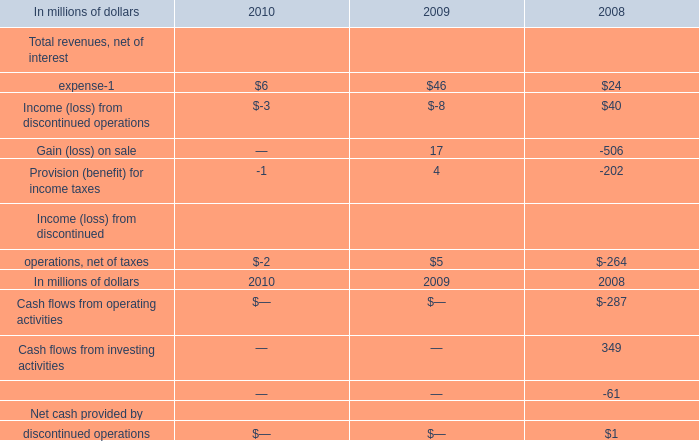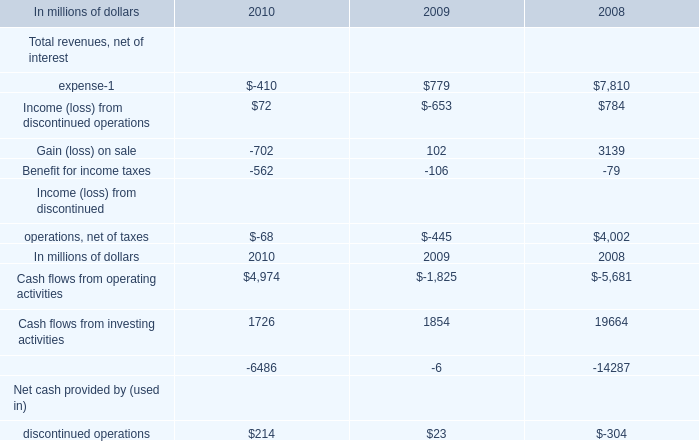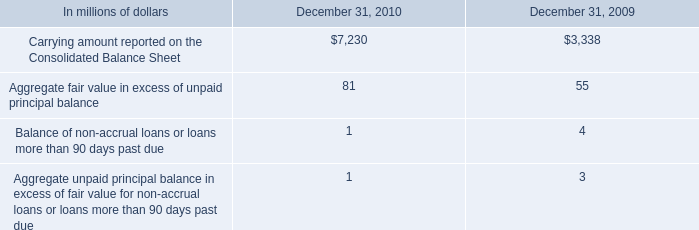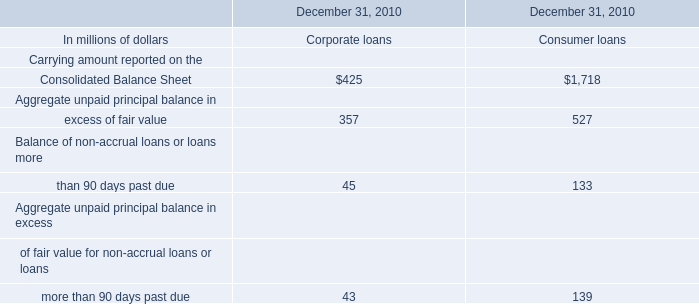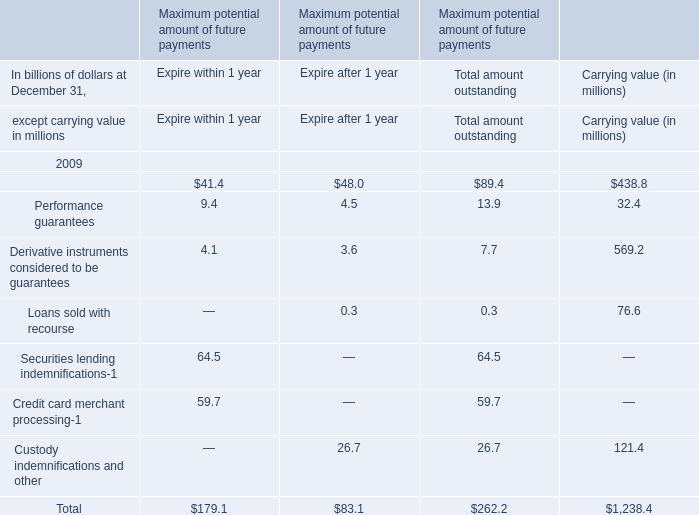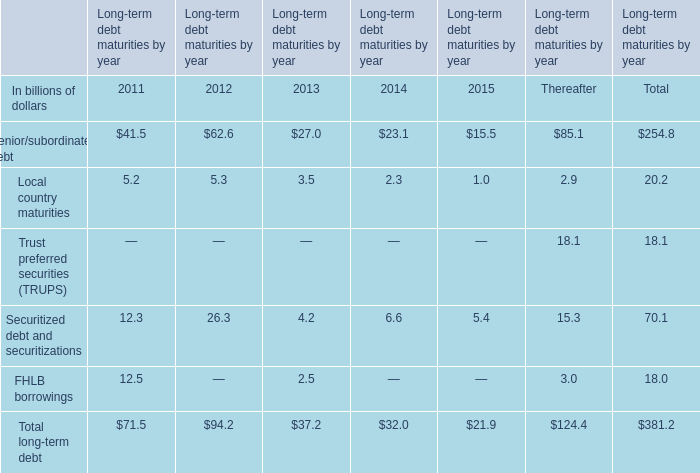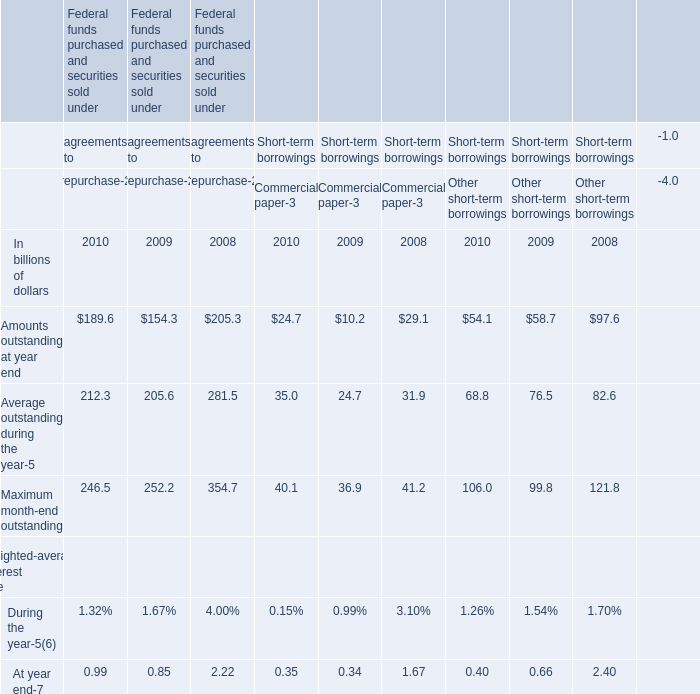What's the total amount of the Total long-term debt in the years where FHLB borrowings is greater than 0? (in billion) 
Computations: (71.5 + 37.2)
Answer: 108.7. 